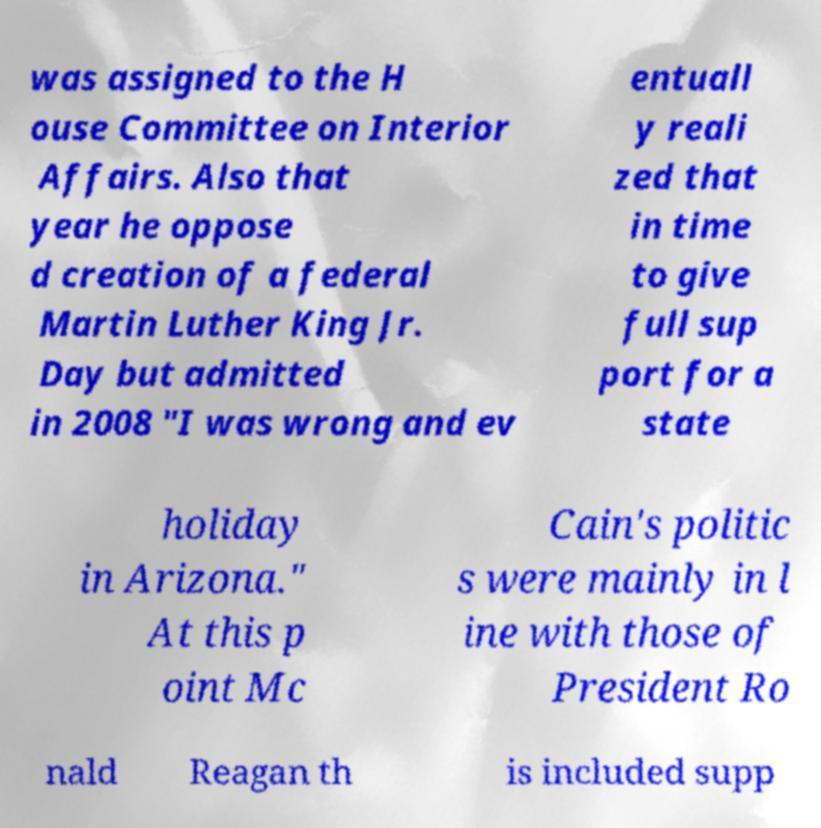Can you read and provide the text displayed in the image?This photo seems to have some interesting text. Can you extract and type it out for me? was assigned to the H ouse Committee on Interior Affairs. Also that year he oppose d creation of a federal Martin Luther King Jr. Day but admitted in 2008 "I was wrong and ev entuall y reali zed that in time to give full sup port for a state holiday in Arizona." At this p oint Mc Cain's politic s were mainly in l ine with those of President Ro nald Reagan th is included supp 